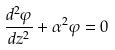Convert formula to latex. <formula><loc_0><loc_0><loc_500><loc_500>\frac { d ^ { 2 } \varphi } { d z ^ { 2 } } + \alpha ^ { 2 } \varphi = 0</formula> 